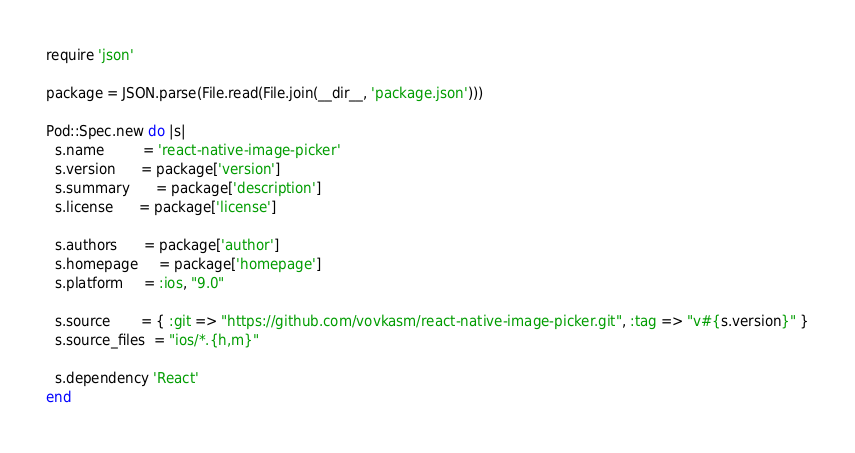<code> <loc_0><loc_0><loc_500><loc_500><_Ruby_>require 'json'

package = JSON.parse(File.read(File.join(__dir__, 'package.json')))

Pod::Spec.new do |s|
  s.name         = 'react-native-image-picker'
  s.version      = package['version']
  s.summary      = package['description']
  s.license      = package['license']

  s.authors      = package['author']
  s.homepage     = package['homepage']
  s.platform     = :ios, "9.0"

  s.source       = { :git => "https://github.com/vovkasm/react-native-image-picker.git", :tag => "v#{s.version}" }
  s.source_files  = "ios/*.{h,m}"

  s.dependency 'React'
end
</code> 